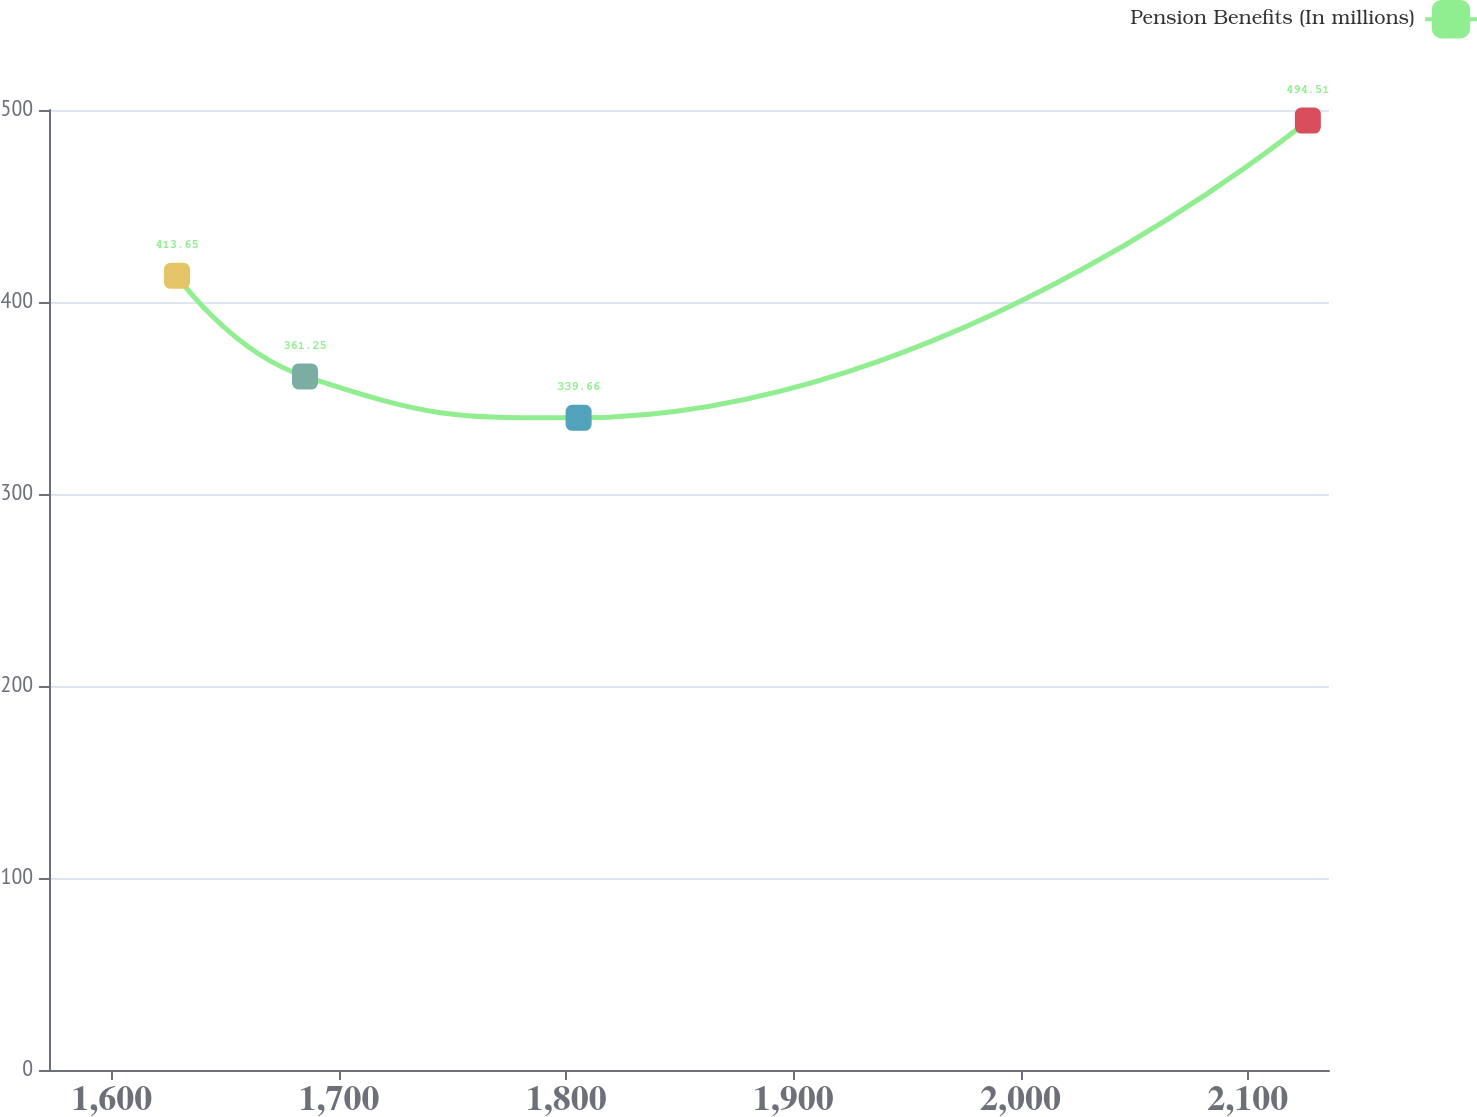Convert chart to OTSL. <chart><loc_0><loc_0><loc_500><loc_500><line_chart><ecel><fcel>Pension Benefits (In millions)<nl><fcel>1628.75<fcel>413.65<nl><fcel>1685.08<fcel>361.25<nl><fcel>1805.49<fcel>339.66<nl><fcel>2126.42<fcel>494.51<nl><fcel>2192.06<fcel>461.47<nl></chart> 